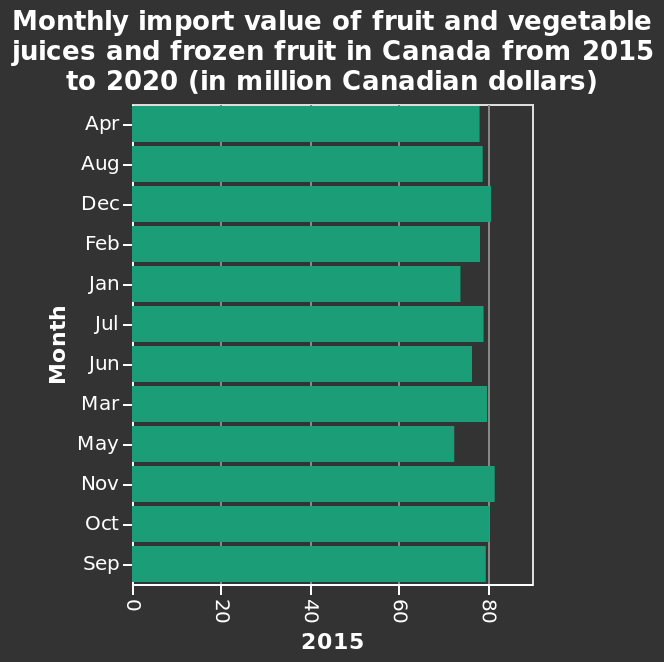<image>
How does the import range vary in the later half of the year? In the later half of the year, the monthly import range becomes bigger. What is shown on the y-axis? On the y-axis, the months are shown. please summary the statistics and relations of the chart On average, each month has seen a monthly import of more than 70 million CAD. Highest months of import are Oct, Nov and Dec, while the lowest seems to be Jan, May and June. Later half of the year has seen a bigger monthly import range. What is the scale used for the x-axis? The scale used for the x-axis is linear. 